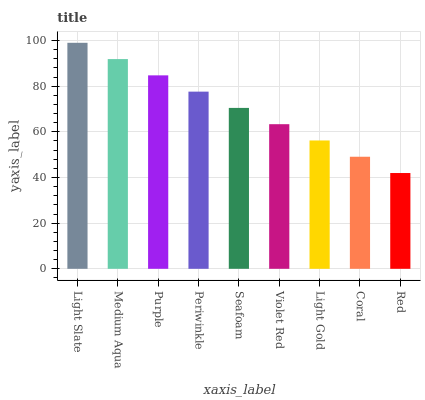Is Medium Aqua the minimum?
Answer yes or no. No. Is Medium Aqua the maximum?
Answer yes or no. No. Is Light Slate greater than Medium Aqua?
Answer yes or no. Yes. Is Medium Aqua less than Light Slate?
Answer yes or no. Yes. Is Medium Aqua greater than Light Slate?
Answer yes or no. No. Is Light Slate less than Medium Aqua?
Answer yes or no. No. Is Seafoam the high median?
Answer yes or no. Yes. Is Seafoam the low median?
Answer yes or no. Yes. Is Purple the high median?
Answer yes or no. No. Is Periwinkle the low median?
Answer yes or no. No. 